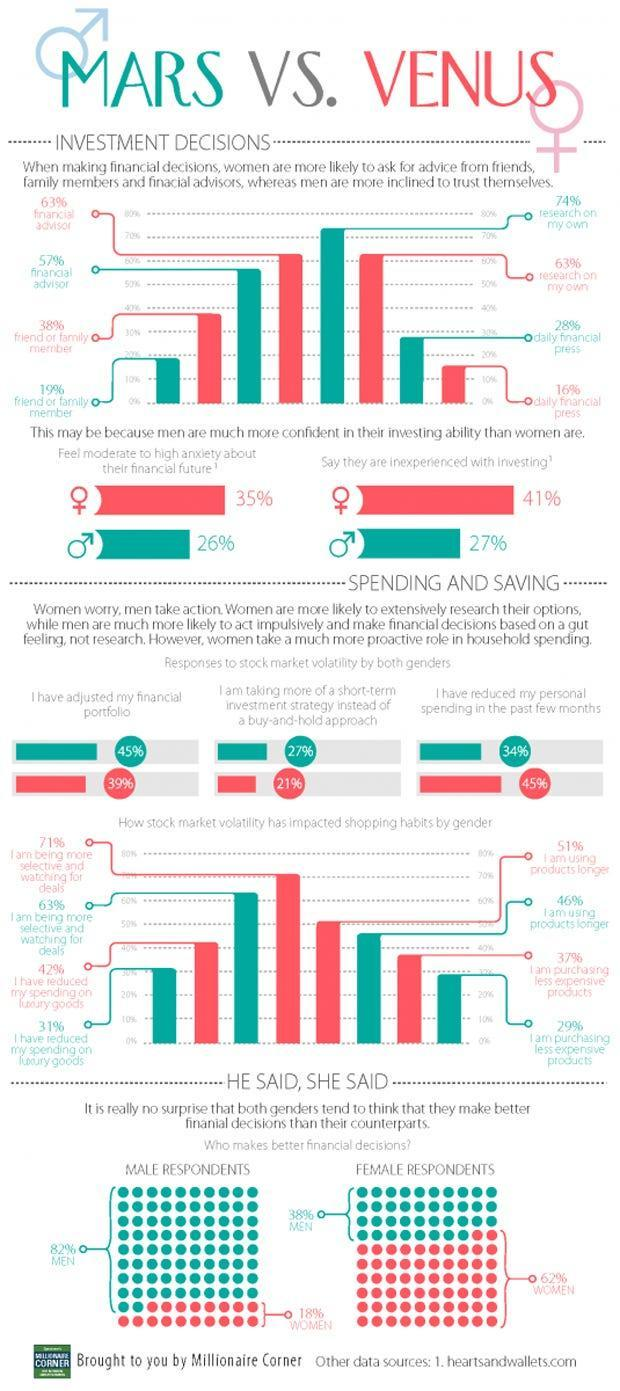What percent of women say that they are inexperienced with investing?
Answer the question with a short phrase. 41% What percent of women ask their friend or family member for financial advice? 38% What percent of men feel moderate to high anxiety about their financial future? 26% What percent of women have adjusted their financial portfolio? 35% What percent of men research on their own according to the bar graph? 74% What percent of men have reduced their personal spending in past few months? 34% 